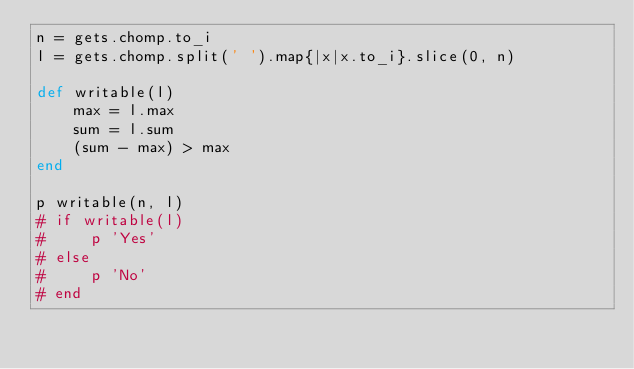<code> <loc_0><loc_0><loc_500><loc_500><_Ruby_>n = gets.chomp.to_i
l = gets.chomp.split(' ').map{|x|x.to_i}.slice(0, n)

def writable(l)
    max = l.max
    sum = l.sum
    (sum - max) > max
end

p writable(n, l)
# if writable(l)
#     p 'Yes'
# else
#     p 'No'
# end</code> 